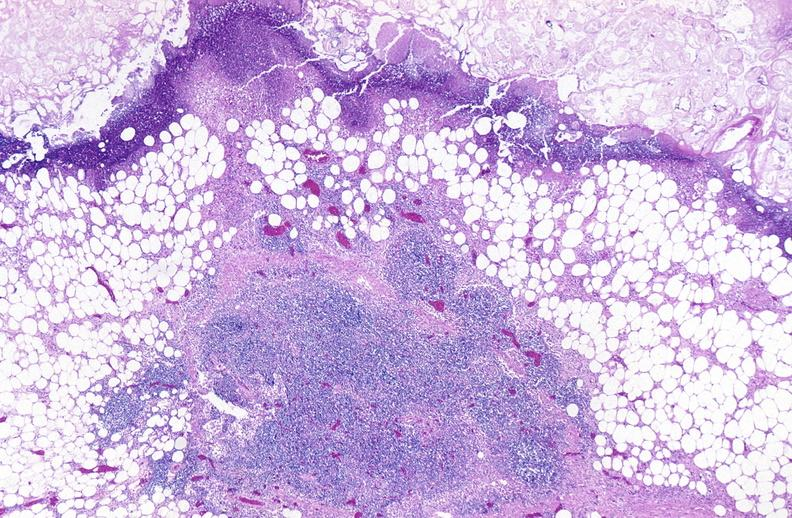does nuclear change show pancreatic fat necrosis?
Answer the question using a single word or phrase. No 